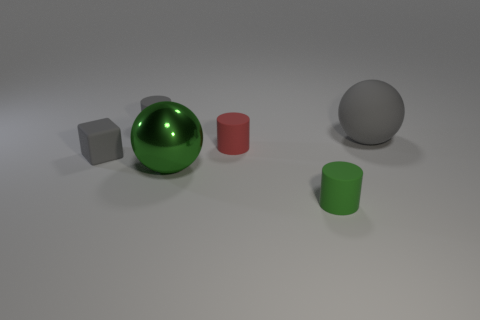What shape is the tiny rubber object that is the same color as the metallic ball?
Give a very brief answer. Cylinder. There is a gray thing on the right side of the large shiny object; what is its size?
Your answer should be very brief. Large. The red matte object that is the same size as the green cylinder is what shape?
Your response must be concise. Cylinder. Are the gray thing that is behind the gray sphere and the small object that is on the left side of the gray cylinder made of the same material?
Your answer should be compact. Yes. There is a large thing that is on the left side of the tiny rubber cylinder that is in front of the shiny ball; what is it made of?
Your response must be concise. Metal. There is a gray object to the right of the gray cylinder that is behind the big ball on the left side of the tiny green cylinder; what size is it?
Offer a very short reply. Large. Does the gray block have the same size as the green ball?
Give a very brief answer. No. There is a tiny thing that is behind the large gray sphere; is its shape the same as the green thing on the left side of the green rubber object?
Keep it short and to the point. No. There is a gray thing to the right of the green sphere; is there a large object right of it?
Your answer should be compact. No. Is there a big red rubber cylinder?
Provide a short and direct response. No. 